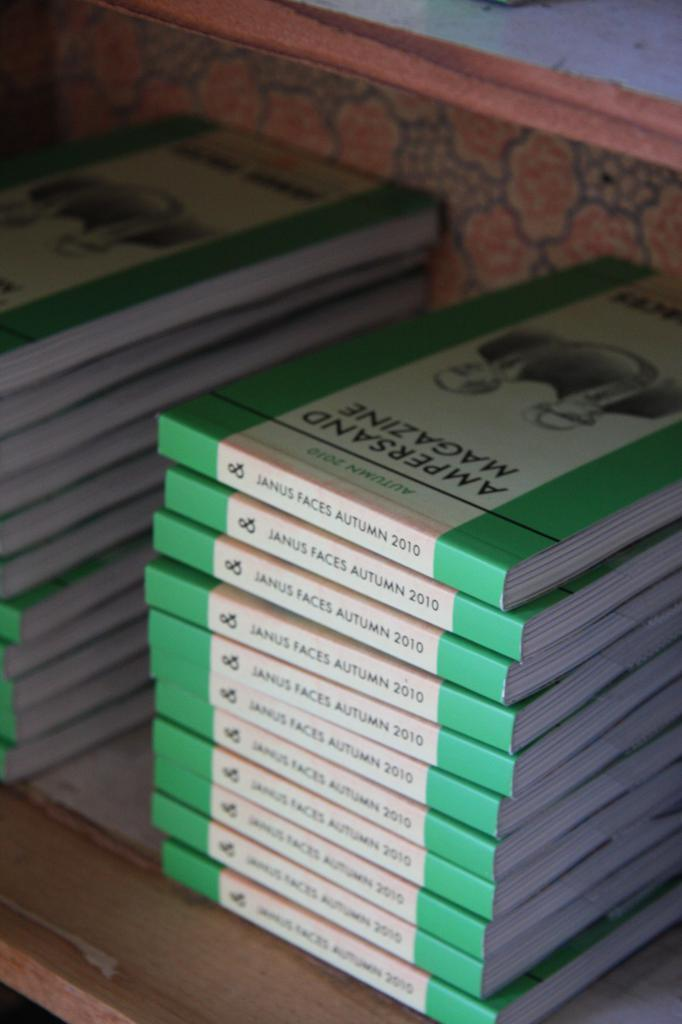<image>
Provide a brief description of the given image. Stack of the same books on top of one another titled "Janus Faces Autumn 2010". 